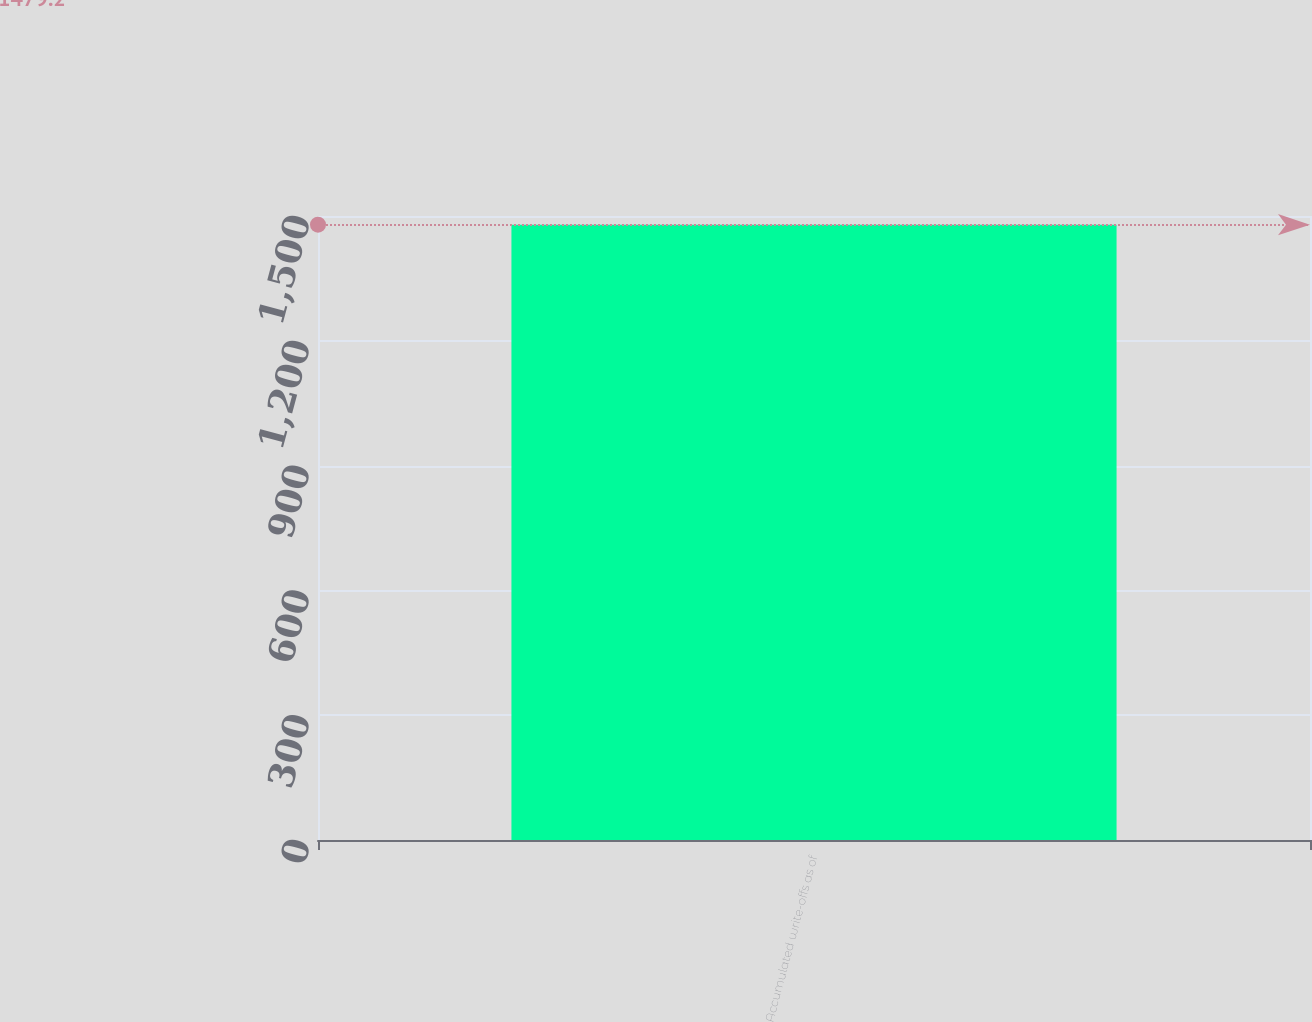<chart> <loc_0><loc_0><loc_500><loc_500><bar_chart><fcel>Accumulated write-offs as of<nl><fcel>1479.2<nl></chart> 